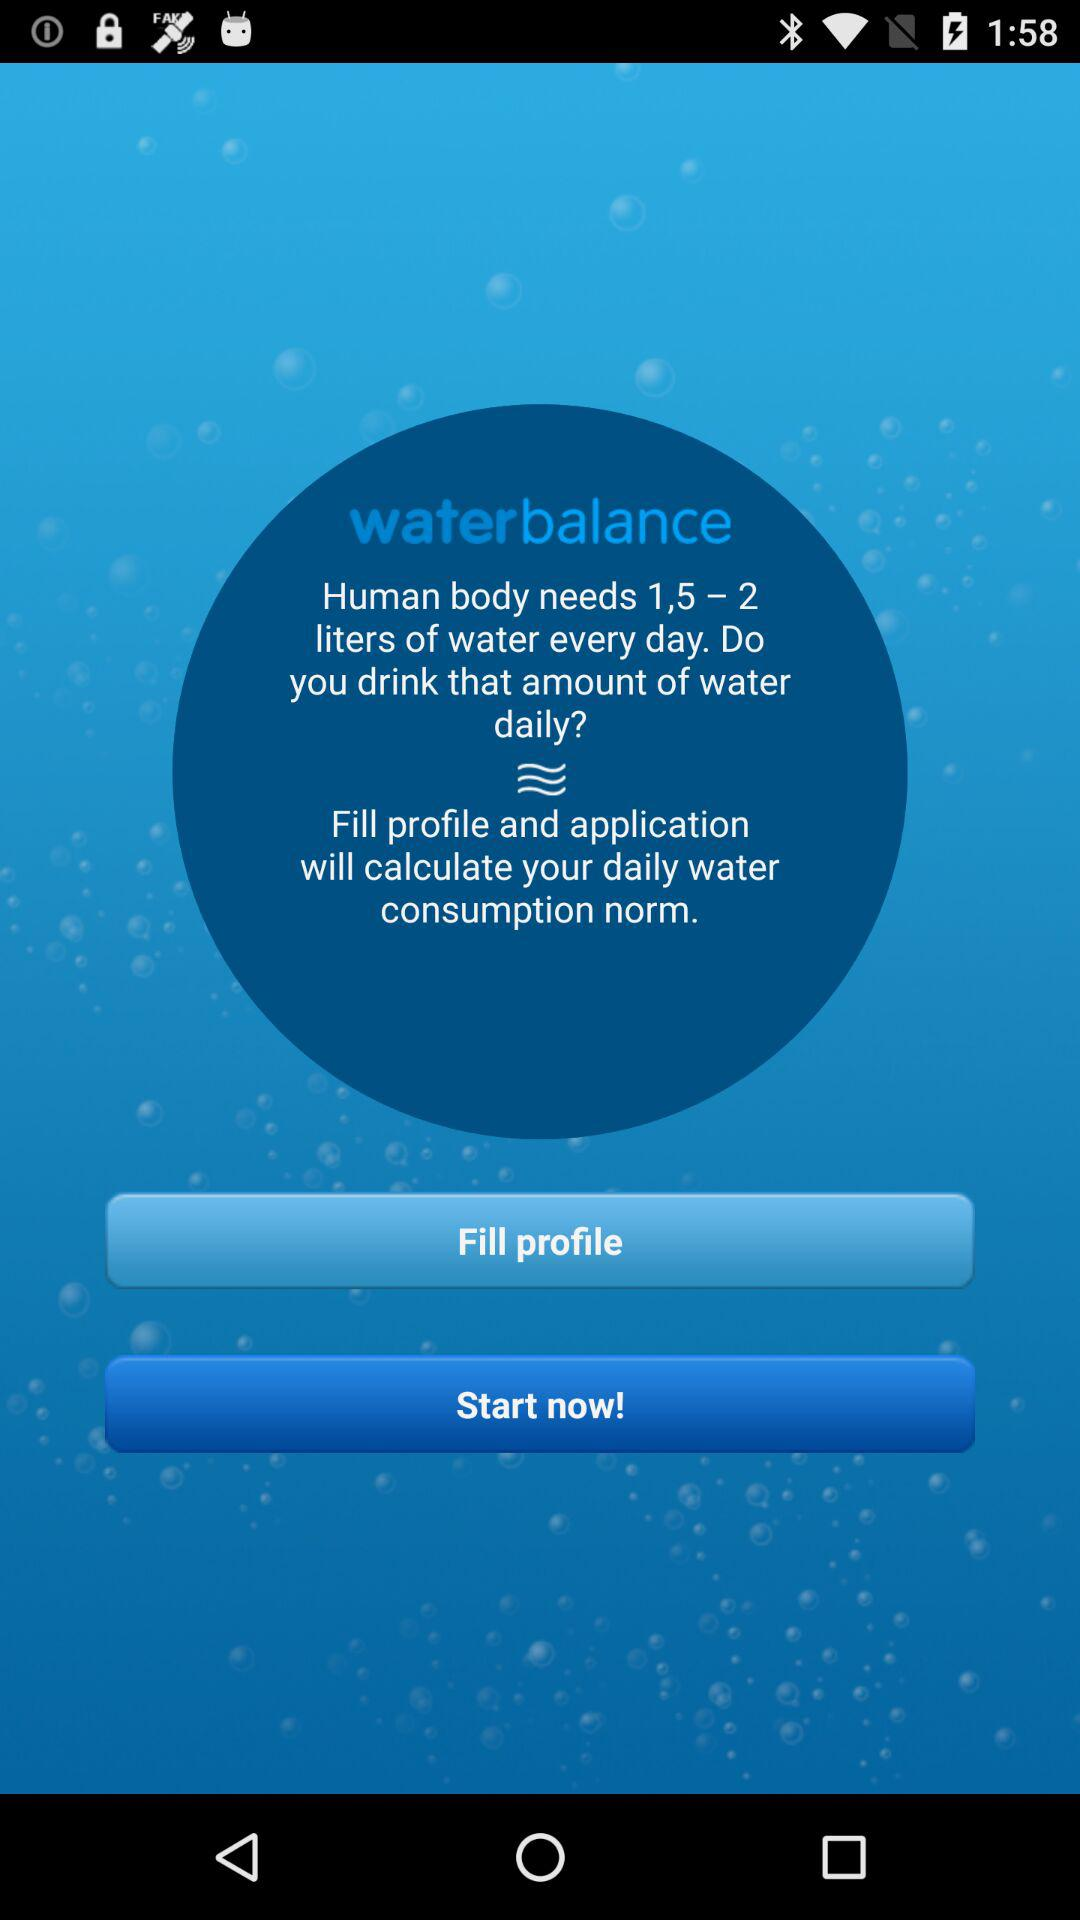How many liters of water does the body need per day?
Answer the question using a single word or phrase. 1.5 - 2 